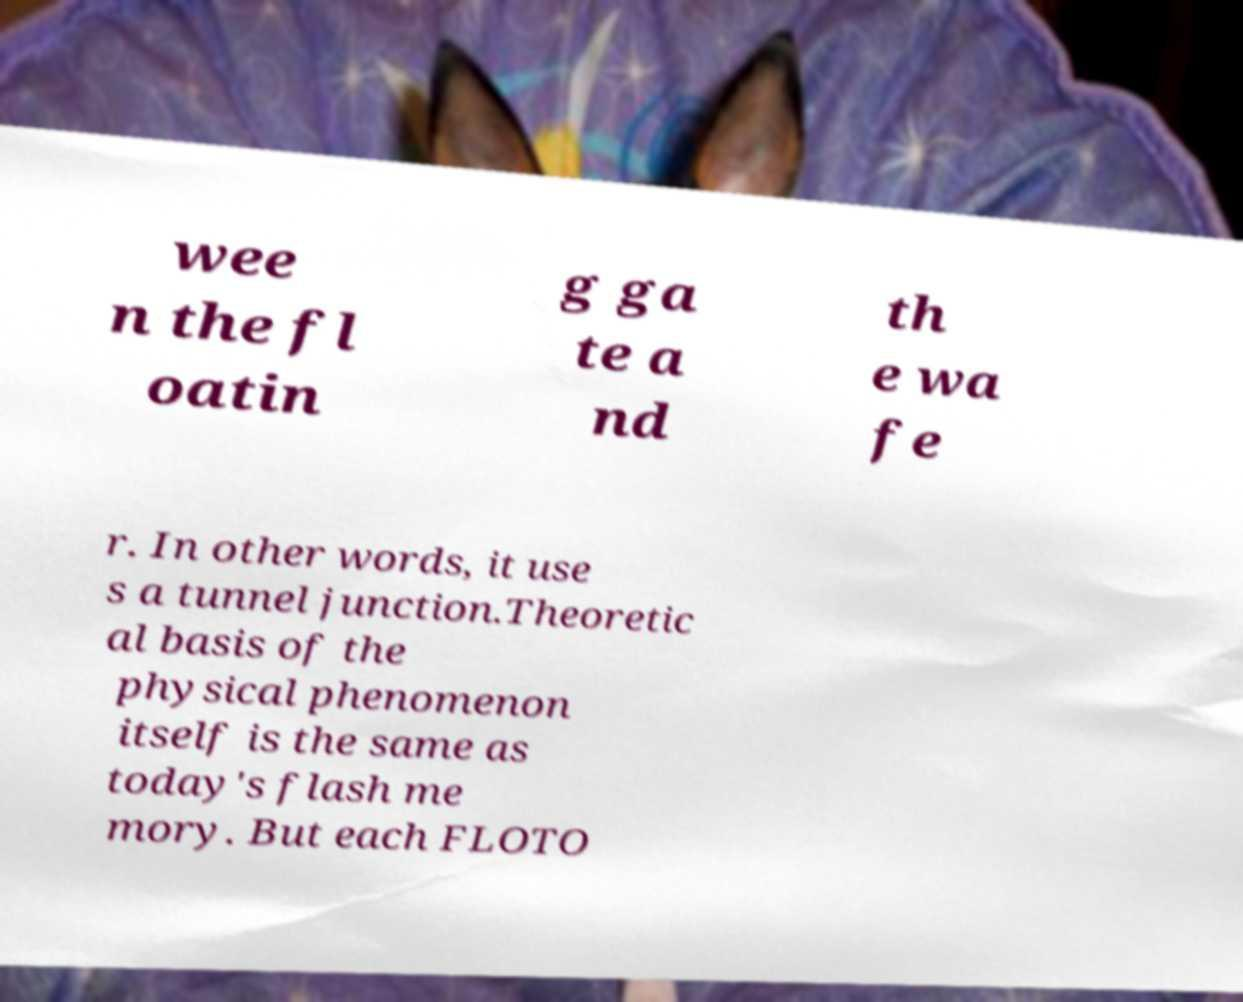Can you accurately transcribe the text from the provided image for me? wee n the fl oatin g ga te a nd th e wa fe r. In other words, it use s a tunnel junction.Theoretic al basis of the physical phenomenon itself is the same as today's flash me mory. But each FLOTO 